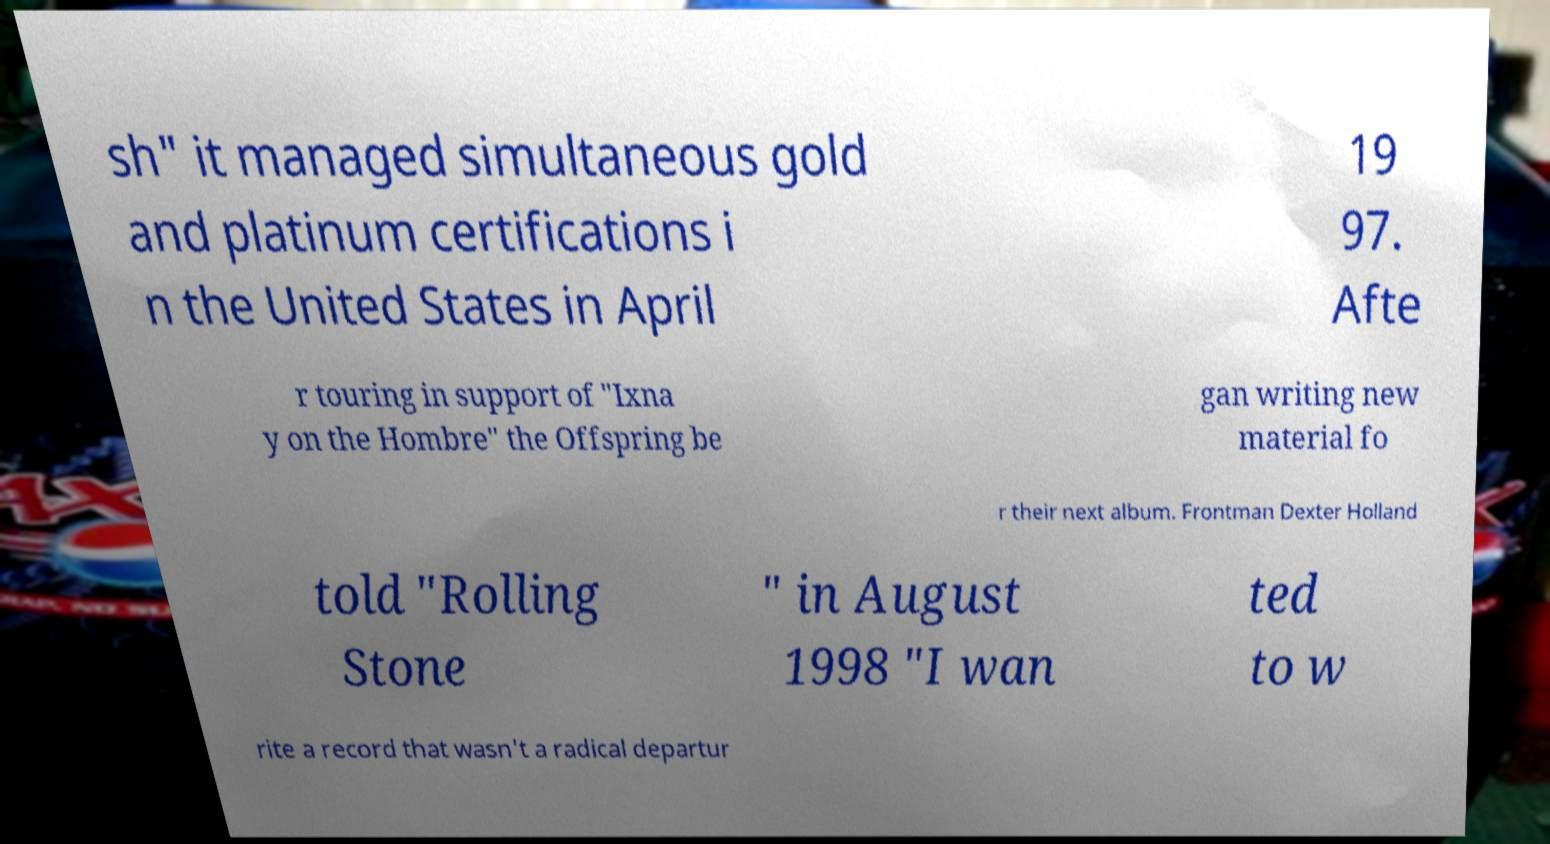Please read and relay the text visible in this image. What does it say? sh" it managed simultaneous gold and platinum certifications i n the United States in April 19 97. Afte r touring in support of "Ixna y on the Hombre" the Offspring be gan writing new material fo r their next album. Frontman Dexter Holland told "Rolling Stone " in August 1998 "I wan ted to w rite a record that wasn't a radical departur 